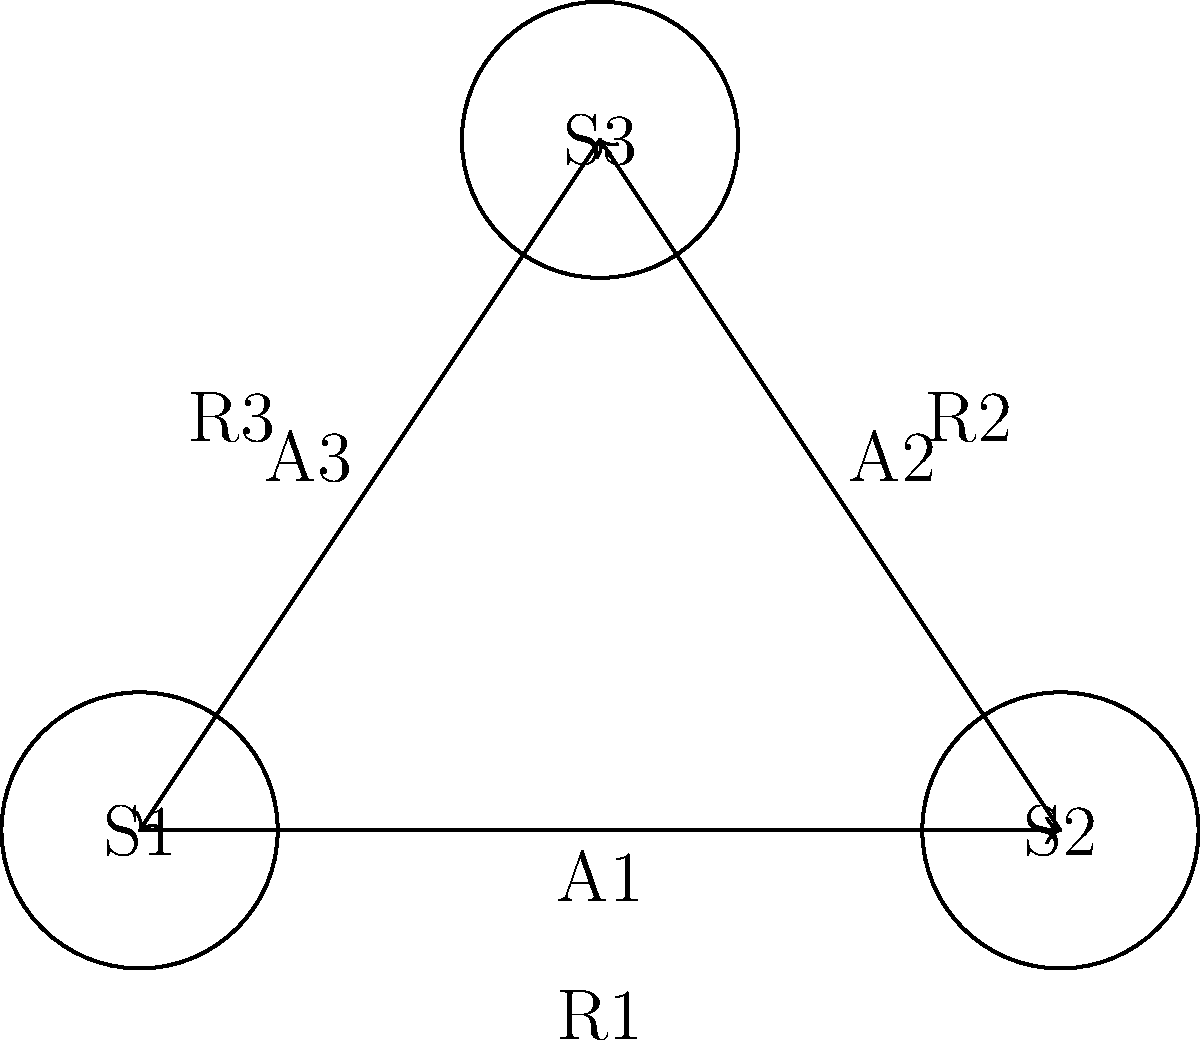Explain the reinforcement learning process using the state-action-reward diagram provided. How does an agent learn to make optimal decisions in this environment? The reinforcement learning process can be explained using this state-action-reward diagram as follows:

1. States: The diagram shows three states (S1, S2, S3) representing different situations the agent can be in.

2. Actions: The arrows between states (A1, A2, A3) represent the actions the agent can take to move from one state to another.

3. Rewards: Each action results in a reward (R1, R2, R3), which provides feedback to the agent about the desirability of that action.

4. Learning process:
   a) The agent starts in an initial state (e.g., S1).
   b) It chooses an action (e.g., A1) based on its current policy.
   c) The environment transitions to a new state (S2) and provides a reward (R1).
   d) The agent updates its value function $Q(s,a)$ for the state-action pair:
      $Q(s,a) = Q(s,a) + \alpha [r + \gamma \max_{a'} Q(s',a') - Q(s,a)]$
      where $\alpha$ is the learning rate, $\gamma$ is the discount factor, $r$ is the reward, and $s'$ is the new state.
   e) The agent updates its policy to favor actions with higher Q-values.

5. Exploration vs. Exploitation: The agent balances exploring new actions (e.g., trying A3 from S1) and exploiting known good actions (e.g., repeatedly taking A1 if it leads to high rewards).

6. Convergence: Over many iterations, the agent learns the optimal policy that maximizes long-term rewards.

This process allows the agent to learn optimal decision-making in the environment without prior knowledge, purely through interaction and feedback.
Answer: Iterative state-action-reward cycles with Q-value updates lead to optimal policy. 